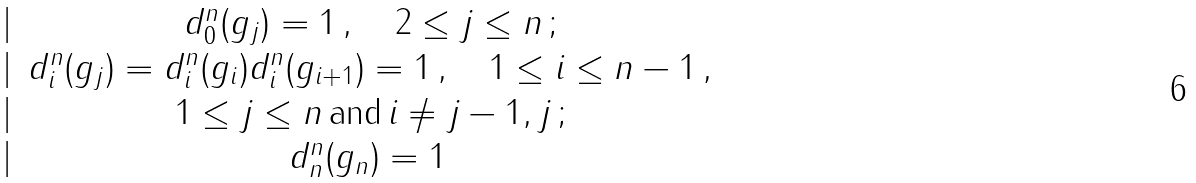<formula> <loc_0><loc_0><loc_500><loc_500>\begin{matrix} | & d ^ { n } _ { 0 } ( g _ { j } ) = 1 \, , \quad 2 \leq j \leq n \, ; \\ | & d ^ { n } _ { i } ( g _ { j } ) = d ^ { n } _ { i } ( g _ { i } ) d ^ { n } _ { i } ( g _ { i + 1 } ) = 1 \, , \quad 1 \leq i \leq n - 1 \, , \\ | & 1 \leq j \leq n \, \text {and} \, i \neq j - 1 , j \, ; \\ | & d ^ { n } _ { n } ( g _ { n } ) = 1 \, \end{matrix}</formula> 